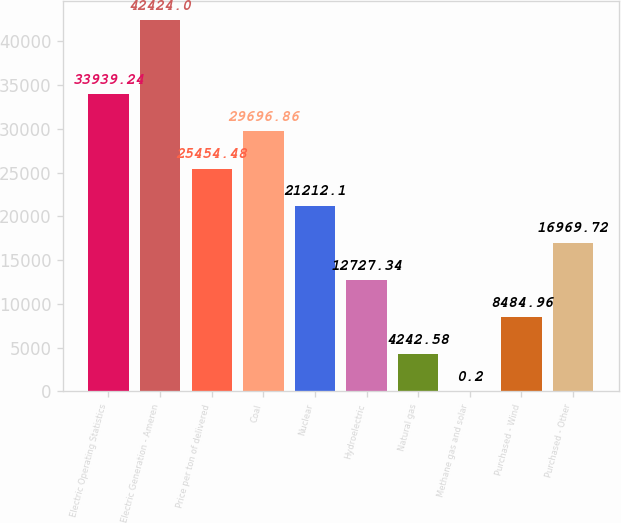Convert chart to OTSL. <chart><loc_0><loc_0><loc_500><loc_500><bar_chart><fcel>Electric Operating Statistics<fcel>Electric Generation - Ameren<fcel>Price per ton of delivered<fcel>Coal<fcel>Nuclear<fcel>Hydroelectric<fcel>Natural gas<fcel>Methane gas and solar<fcel>Purchased - Wind<fcel>Purchased - Other<nl><fcel>33939.2<fcel>42424<fcel>25454.5<fcel>29696.9<fcel>21212.1<fcel>12727.3<fcel>4242.58<fcel>0.2<fcel>8484.96<fcel>16969.7<nl></chart> 